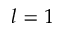Convert formula to latex. <formula><loc_0><loc_0><loc_500><loc_500>l = 1</formula> 